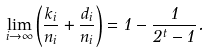<formula> <loc_0><loc_0><loc_500><loc_500>\lim _ { i \rightarrow \infty } \left ( \frac { k _ { i } } { n _ { i } } + \frac { d _ { i } } { n _ { i } } \right ) = 1 - \frac { 1 } { 2 ^ { t } - 1 } .</formula> 